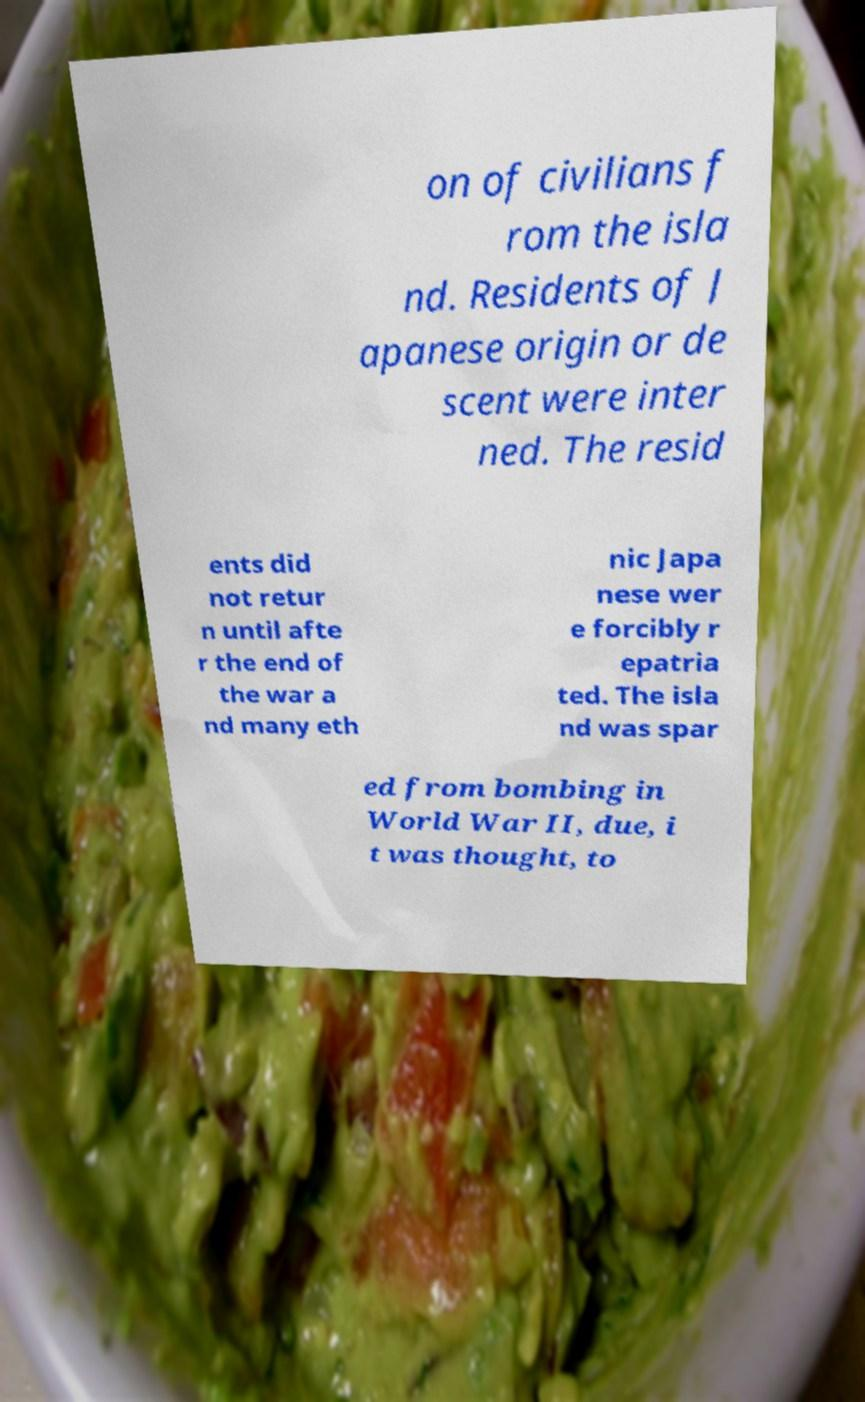Could you assist in decoding the text presented in this image and type it out clearly? on of civilians f rom the isla nd. Residents of J apanese origin or de scent were inter ned. The resid ents did not retur n until afte r the end of the war a nd many eth nic Japa nese wer e forcibly r epatria ted. The isla nd was spar ed from bombing in World War II, due, i t was thought, to 